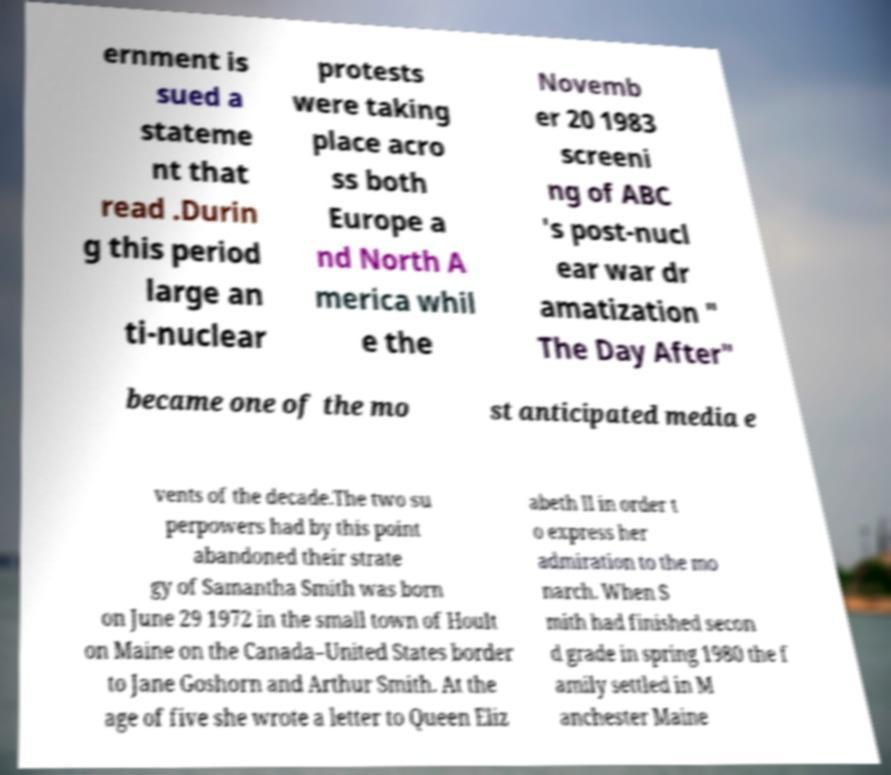I need the written content from this picture converted into text. Can you do that? ernment is sued a stateme nt that read .Durin g this period large an ti-nuclear protests were taking place acro ss both Europe a nd North A merica whil e the Novemb er 20 1983 screeni ng of ABC 's post-nucl ear war dr amatization " The Day After" became one of the mo st anticipated media e vents of the decade.The two su perpowers had by this point abandoned their strate gy of Samantha Smith was born on June 29 1972 in the small town of Hoult on Maine on the Canada–United States border to Jane Goshorn and Arthur Smith. At the age of five she wrote a letter to Queen Eliz abeth II in order t o express her admiration to the mo narch. When S mith had finished secon d grade in spring 1980 the f amily settled in M anchester Maine 